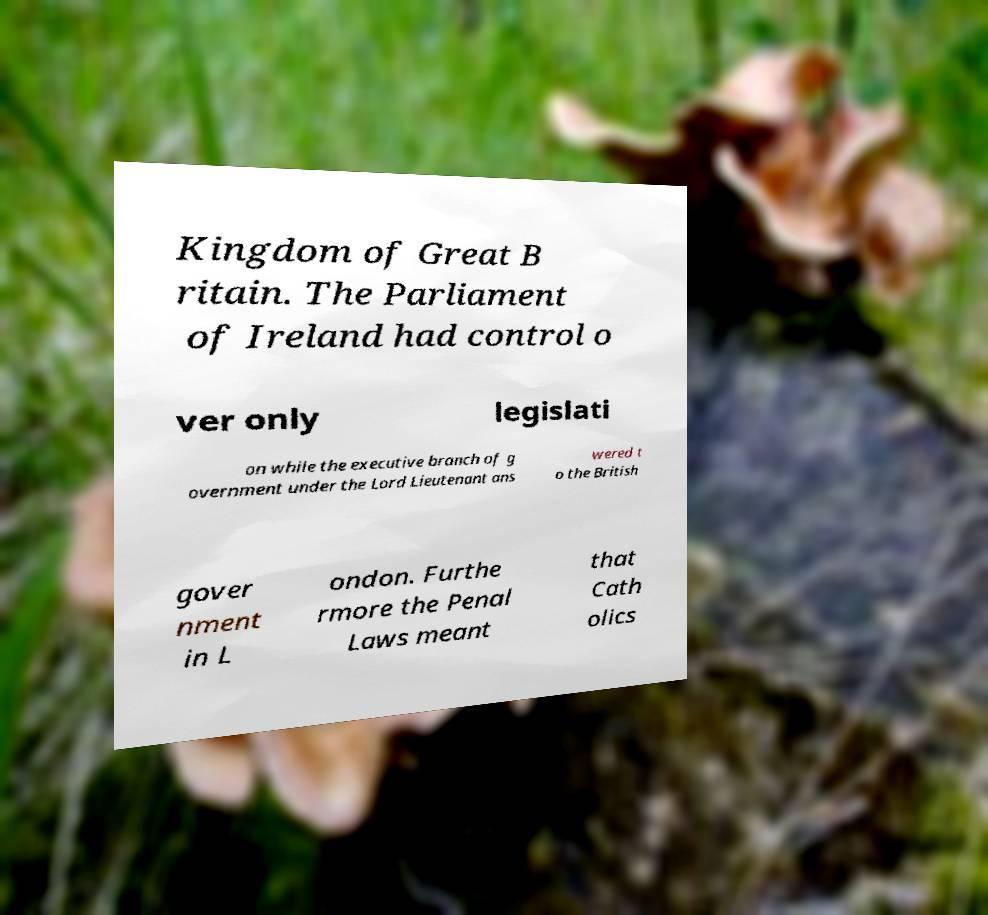Can you accurately transcribe the text from the provided image for me? Kingdom of Great B ritain. The Parliament of Ireland had control o ver only legislati on while the executive branch of g overnment under the Lord Lieutenant ans wered t o the British gover nment in L ondon. Furthe rmore the Penal Laws meant that Cath olics 